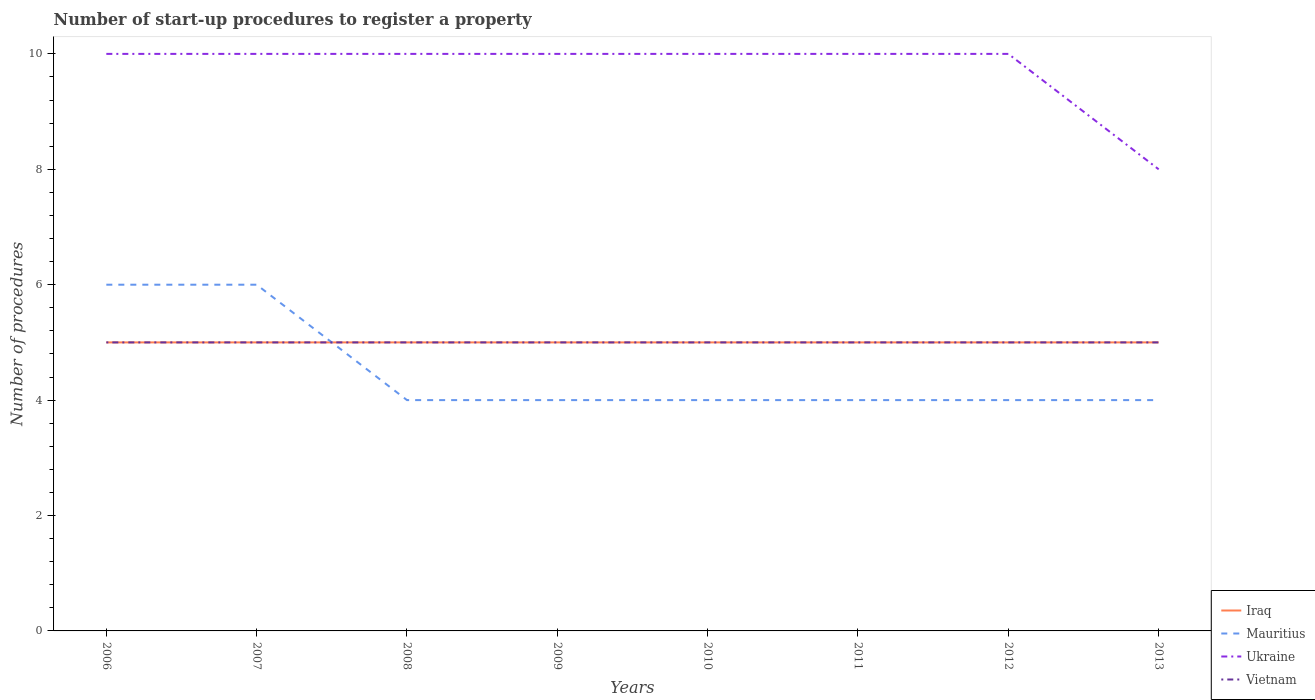Does the line corresponding to Mauritius intersect with the line corresponding to Iraq?
Your response must be concise. Yes. Is the number of lines equal to the number of legend labels?
Your answer should be compact. Yes. Across all years, what is the maximum number of procedures required to register a property in Mauritius?
Offer a terse response. 4. What is the difference between the highest and the second highest number of procedures required to register a property in Ukraine?
Ensure brevity in your answer.  2. How many years are there in the graph?
Offer a very short reply. 8. What is the difference between two consecutive major ticks on the Y-axis?
Keep it short and to the point. 2. Where does the legend appear in the graph?
Provide a short and direct response. Bottom right. How many legend labels are there?
Your answer should be very brief. 4. How are the legend labels stacked?
Provide a short and direct response. Vertical. What is the title of the graph?
Make the answer very short. Number of start-up procedures to register a property. What is the label or title of the X-axis?
Your answer should be very brief. Years. What is the label or title of the Y-axis?
Provide a succinct answer. Number of procedures. What is the Number of procedures of Iraq in 2006?
Your answer should be very brief. 5. What is the Number of procedures of Mauritius in 2006?
Make the answer very short. 6. What is the Number of procedures of Vietnam in 2006?
Your answer should be very brief. 5. What is the Number of procedures in Mauritius in 2007?
Offer a terse response. 6. What is the Number of procedures in Ukraine in 2007?
Keep it short and to the point. 10. What is the Number of procedures in Ukraine in 2008?
Offer a very short reply. 10. What is the Number of procedures of Mauritius in 2009?
Offer a terse response. 4. What is the Number of procedures of Ukraine in 2009?
Offer a terse response. 10. What is the Number of procedures of Vietnam in 2009?
Provide a succinct answer. 5. What is the Number of procedures in Iraq in 2010?
Your response must be concise. 5. What is the Number of procedures of Mauritius in 2010?
Give a very brief answer. 4. What is the Number of procedures of Mauritius in 2011?
Provide a short and direct response. 4. What is the Number of procedures of Ukraine in 2011?
Offer a very short reply. 10. What is the Number of procedures in Vietnam in 2012?
Your response must be concise. 5. What is the Number of procedures of Mauritius in 2013?
Keep it short and to the point. 4. What is the Number of procedures in Ukraine in 2013?
Ensure brevity in your answer.  8. What is the Number of procedures of Vietnam in 2013?
Make the answer very short. 5. Across all years, what is the maximum Number of procedures in Ukraine?
Make the answer very short. 10. Across all years, what is the minimum Number of procedures in Mauritius?
Your answer should be compact. 4. Across all years, what is the minimum Number of procedures in Ukraine?
Provide a short and direct response. 8. What is the total Number of procedures in Mauritius in the graph?
Provide a succinct answer. 36. What is the total Number of procedures in Ukraine in the graph?
Provide a short and direct response. 78. What is the total Number of procedures of Vietnam in the graph?
Make the answer very short. 40. What is the difference between the Number of procedures in Iraq in 2006 and that in 2007?
Give a very brief answer. 0. What is the difference between the Number of procedures in Vietnam in 2006 and that in 2007?
Keep it short and to the point. 0. What is the difference between the Number of procedures of Iraq in 2006 and that in 2008?
Your answer should be compact. 0. What is the difference between the Number of procedures of Vietnam in 2006 and that in 2008?
Ensure brevity in your answer.  0. What is the difference between the Number of procedures of Iraq in 2006 and that in 2009?
Give a very brief answer. 0. What is the difference between the Number of procedures of Ukraine in 2006 and that in 2009?
Your answer should be very brief. 0. What is the difference between the Number of procedures in Vietnam in 2006 and that in 2009?
Your answer should be very brief. 0. What is the difference between the Number of procedures of Mauritius in 2006 and that in 2010?
Offer a very short reply. 2. What is the difference between the Number of procedures of Ukraine in 2006 and that in 2010?
Provide a succinct answer. 0. What is the difference between the Number of procedures of Vietnam in 2006 and that in 2010?
Keep it short and to the point. 0. What is the difference between the Number of procedures in Ukraine in 2006 and that in 2011?
Provide a succinct answer. 0. What is the difference between the Number of procedures of Vietnam in 2006 and that in 2011?
Your answer should be compact. 0. What is the difference between the Number of procedures of Ukraine in 2006 and that in 2012?
Your answer should be compact. 0. What is the difference between the Number of procedures in Vietnam in 2006 and that in 2012?
Provide a succinct answer. 0. What is the difference between the Number of procedures of Iraq in 2006 and that in 2013?
Keep it short and to the point. 0. What is the difference between the Number of procedures of Mauritius in 2006 and that in 2013?
Keep it short and to the point. 2. What is the difference between the Number of procedures in Vietnam in 2006 and that in 2013?
Give a very brief answer. 0. What is the difference between the Number of procedures of Iraq in 2007 and that in 2008?
Your response must be concise. 0. What is the difference between the Number of procedures of Vietnam in 2007 and that in 2008?
Ensure brevity in your answer.  0. What is the difference between the Number of procedures in Ukraine in 2007 and that in 2009?
Provide a short and direct response. 0. What is the difference between the Number of procedures in Iraq in 2007 and that in 2011?
Ensure brevity in your answer.  0. What is the difference between the Number of procedures of Ukraine in 2007 and that in 2011?
Make the answer very short. 0. What is the difference between the Number of procedures in Vietnam in 2007 and that in 2011?
Your response must be concise. 0. What is the difference between the Number of procedures of Mauritius in 2007 and that in 2012?
Offer a terse response. 2. What is the difference between the Number of procedures in Mauritius in 2008 and that in 2009?
Your answer should be compact. 0. What is the difference between the Number of procedures of Ukraine in 2008 and that in 2009?
Offer a terse response. 0. What is the difference between the Number of procedures of Vietnam in 2008 and that in 2009?
Offer a very short reply. 0. What is the difference between the Number of procedures in Iraq in 2008 and that in 2010?
Provide a short and direct response. 0. What is the difference between the Number of procedures of Ukraine in 2008 and that in 2010?
Offer a very short reply. 0. What is the difference between the Number of procedures of Vietnam in 2008 and that in 2010?
Ensure brevity in your answer.  0. What is the difference between the Number of procedures in Mauritius in 2008 and that in 2012?
Your response must be concise. 0. What is the difference between the Number of procedures of Iraq in 2008 and that in 2013?
Make the answer very short. 0. What is the difference between the Number of procedures in Ukraine in 2008 and that in 2013?
Offer a terse response. 2. What is the difference between the Number of procedures of Mauritius in 2009 and that in 2010?
Offer a very short reply. 0. What is the difference between the Number of procedures in Vietnam in 2009 and that in 2010?
Provide a succinct answer. 0. What is the difference between the Number of procedures in Mauritius in 2009 and that in 2011?
Ensure brevity in your answer.  0. What is the difference between the Number of procedures of Ukraine in 2009 and that in 2011?
Ensure brevity in your answer.  0. What is the difference between the Number of procedures of Vietnam in 2009 and that in 2011?
Keep it short and to the point. 0. What is the difference between the Number of procedures of Iraq in 2009 and that in 2012?
Make the answer very short. 0. What is the difference between the Number of procedures in Vietnam in 2009 and that in 2012?
Your answer should be compact. 0. What is the difference between the Number of procedures of Ukraine in 2009 and that in 2013?
Keep it short and to the point. 2. What is the difference between the Number of procedures of Iraq in 2010 and that in 2011?
Offer a terse response. 0. What is the difference between the Number of procedures of Mauritius in 2010 and that in 2011?
Your answer should be very brief. 0. What is the difference between the Number of procedures in Ukraine in 2010 and that in 2011?
Ensure brevity in your answer.  0. What is the difference between the Number of procedures of Vietnam in 2010 and that in 2011?
Ensure brevity in your answer.  0. What is the difference between the Number of procedures of Iraq in 2010 and that in 2012?
Ensure brevity in your answer.  0. What is the difference between the Number of procedures of Mauritius in 2010 and that in 2012?
Make the answer very short. 0. What is the difference between the Number of procedures of Iraq in 2010 and that in 2013?
Your answer should be very brief. 0. What is the difference between the Number of procedures of Mauritius in 2010 and that in 2013?
Your response must be concise. 0. What is the difference between the Number of procedures in Vietnam in 2010 and that in 2013?
Offer a very short reply. 0. What is the difference between the Number of procedures of Iraq in 2011 and that in 2012?
Offer a terse response. 0. What is the difference between the Number of procedures in Mauritius in 2011 and that in 2012?
Your response must be concise. 0. What is the difference between the Number of procedures in Iraq in 2011 and that in 2013?
Provide a succinct answer. 0. What is the difference between the Number of procedures in Ukraine in 2011 and that in 2013?
Provide a succinct answer. 2. What is the difference between the Number of procedures in Mauritius in 2012 and that in 2013?
Your response must be concise. 0. What is the difference between the Number of procedures of Ukraine in 2012 and that in 2013?
Provide a succinct answer. 2. What is the difference between the Number of procedures of Vietnam in 2012 and that in 2013?
Your answer should be compact. 0. What is the difference between the Number of procedures of Iraq in 2006 and the Number of procedures of Mauritius in 2007?
Provide a succinct answer. -1. What is the difference between the Number of procedures in Iraq in 2006 and the Number of procedures in Ukraine in 2007?
Offer a very short reply. -5. What is the difference between the Number of procedures of Mauritius in 2006 and the Number of procedures of Ukraine in 2007?
Offer a very short reply. -4. What is the difference between the Number of procedures of Iraq in 2006 and the Number of procedures of Mauritius in 2008?
Provide a short and direct response. 1. What is the difference between the Number of procedures in Iraq in 2006 and the Number of procedures in Ukraine in 2008?
Your answer should be compact. -5. What is the difference between the Number of procedures of Iraq in 2006 and the Number of procedures of Vietnam in 2008?
Provide a succinct answer. 0. What is the difference between the Number of procedures in Mauritius in 2006 and the Number of procedures in Ukraine in 2008?
Offer a terse response. -4. What is the difference between the Number of procedures in Mauritius in 2006 and the Number of procedures in Vietnam in 2008?
Ensure brevity in your answer.  1. What is the difference between the Number of procedures of Iraq in 2006 and the Number of procedures of Mauritius in 2009?
Your response must be concise. 1. What is the difference between the Number of procedures of Iraq in 2006 and the Number of procedures of Ukraine in 2009?
Make the answer very short. -5. What is the difference between the Number of procedures of Iraq in 2006 and the Number of procedures of Vietnam in 2009?
Offer a very short reply. 0. What is the difference between the Number of procedures in Iraq in 2006 and the Number of procedures in Ukraine in 2010?
Your answer should be very brief. -5. What is the difference between the Number of procedures in Iraq in 2006 and the Number of procedures in Vietnam in 2010?
Make the answer very short. 0. What is the difference between the Number of procedures of Mauritius in 2006 and the Number of procedures of Vietnam in 2010?
Provide a succinct answer. 1. What is the difference between the Number of procedures of Mauritius in 2006 and the Number of procedures of Ukraine in 2011?
Your answer should be very brief. -4. What is the difference between the Number of procedures of Mauritius in 2006 and the Number of procedures of Vietnam in 2011?
Offer a terse response. 1. What is the difference between the Number of procedures of Iraq in 2006 and the Number of procedures of Ukraine in 2012?
Offer a very short reply. -5. What is the difference between the Number of procedures in Iraq in 2006 and the Number of procedures in Vietnam in 2012?
Offer a terse response. 0. What is the difference between the Number of procedures in Mauritius in 2006 and the Number of procedures in Ukraine in 2012?
Your response must be concise. -4. What is the difference between the Number of procedures of Mauritius in 2006 and the Number of procedures of Vietnam in 2012?
Provide a succinct answer. 1. What is the difference between the Number of procedures in Iraq in 2006 and the Number of procedures in Mauritius in 2013?
Your answer should be very brief. 1. What is the difference between the Number of procedures of Mauritius in 2006 and the Number of procedures of Vietnam in 2013?
Give a very brief answer. 1. What is the difference between the Number of procedures of Iraq in 2007 and the Number of procedures of Mauritius in 2008?
Keep it short and to the point. 1. What is the difference between the Number of procedures in Iraq in 2007 and the Number of procedures in Ukraine in 2008?
Your answer should be compact. -5. What is the difference between the Number of procedures in Iraq in 2007 and the Number of procedures in Vietnam in 2008?
Your response must be concise. 0. What is the difference between the Number of procedures of Mauritius in 2007 and the Number of procedures of Vietnam in 2008?
Offer a very short reply. 1. What is the difference between the Number of procedures of Iraq in 2007 and the Number of procedures of Ukraine in 2009?
Ensure brevity in your answer.  -5. What is the difference between the Number of procedures in Iraq in 2007 and the Number of procedures in Vietnam in 2009?
Your response must be concise. 0. What is the difference between the Number of procedures in Mauritius in 2007 and the Number of procedures in Ukraine in 2009?
Offer a terse response. -4. What is the difference between the Number of procedures of Iraq in 2007 and the Number of procedures of Ukraine in 2010?
Keep it short and to the point. -5. What is the difference between the Number of procedures in Mauritius in 2007 and the Number of procedures in Vietnam in 2010?
Your response must be concise. 1. What is the difference between the Number of procedures in Mauritius in 2007 and the Number of procedures in Ukraine in 2011?
Your answer should be very brief. -4. What is the difference between the Number of procedures of Mauritius in 2007 and the Number of procedures of Vietnam in 2011?
Your answer should be compact. 1. What is the difference between the Number of procedures of Ukraine in 2007 and the Number of procedures of Vietnam in 2011?
Give a very brief answer. 5. What is the difference between the Number of procedures of Iraq in 2007 and the Number of procedures of Ukraine in 2012?
Your response must be concise. -5. What is the difference between the Number of procedures of Mauritius in 2007 and the Number of procedures of Vietnam in 2012?
Provide a succinct answer. 1. What is the difference between the Number of procedures of Ukraine in 2007 and the Number of procedures of Vietnam in 2012?
Keep it short and to the point. 5. What is the difference between the Number of procedures of Iraq in 2007 and the Number of procedures of Mauritius in 2013?
Provide a short and direct response. 1. What is the difference between the Number of procedures in Iraq in 2007 and the Number of procedures in Ukraine in 2013?
Keep it short and to the point. -3. What is the difference between the Number of procedures of Iraq in 2008 and the Number of procedures of Ukraine in 2009?
Ensure brevity in your answer.  -5. What is the difference between the Number of procedures of Iraq in 2008 and the Number of procedures of Vietnam in 2009?
Your answer should be very brief. 0. What is the difference between the Number of procedures in Mauritius in 2008 and the Number of procedures in Ukraine in 2009?
Ensure brevity in your answer.  -6. What is the difference between the Number of procedures in Ukraine in 2008 and the Number of procedures in Vietnam in 2009?
Ensure brevity in your answer.  5. What is the difference between the Number of procedures in Iraq in 2008 and the Number of procedures in Mauritius in 2010?
Offer a very short reply. 1. What is the difference between the Number of procedures in Iraq in 2008 and the Number of procedures in Ukraine in 2010?
Provide a succinct answer. -5. What is the difference between the Number of procedures in Iraq in 2008 and the Number of procedures in Vietnam in 2010?
Provide a short and direct response. 0. What is the difference between the Number of procedures of Mauritius in 2008 and the Number of procedures of Vietnam in 2010?
Keep it short and to the point. -1. What is the difference between the Number of procedures of Iraq in 2008 and the Number of procedures of Mauritius in 2011?
Provide a succinct answer. 1. What is the difference between the Number of procedures of Iraq in 2008 and the Number of procedures of Ukraine in 2011?
Make the answer very short. -5. What is the difference between the Number of procedures in Iraq in 2008 and the Number of procedures in Vietnam in 2011?
Give a very brief answer. 0. What is the difference between the Number of procedures of Ukraine in 2008 and the Number of procedures of Vietnam in 2011?
Your response must be concise. 5. What is the difference between the Number of procedures of Iraq in 2008 and the Number of procedures of Mauritius in 2012?
Make the answer very short. 1. What is the difference between the Number of procedures of Iraq in 2008 and the Number of procedures of Ukraine in 2012?
Provide a succinct answer. -5. What is the difference between the Number of procedures in Mauritius in 2008 and the Number of procedures in Ukraine in 2012?
Provide a succinct answer. -6. What is the difference between the Number of procedures in Mauritius in 2008 and the Number of procedures in Vietnam in 2012?
Your answer should be very brief. -1. What is the difference between the Number of procedures of Ukraine in 2008 and the Number of procedures of Vietnam in 2012?
Your response must be concise. 5. What is the difference between the Number of procedures of Iraq in 2008 and the Number of procedures of Ukraine in 2013?
Provide a succinct answer. -3. What is the difference between the Number of procedures of Iraq in 2008 and the Number of procedures of Vietnam in 2013?
Your answer should be very brief. 0. What is the difference between the Number of procedures of Mauritius in 2008 and the Number of procedures of Ukraine in 2013?
Ensure brevity in your answer.  -4. What is the difference between the Number of procedures in Mauritius in 2008 and the Number of procedures in Vietnam in 2013?
Offer a very short reply. -1. What is the difference between the Number of procedures in Iraq in 2009 and the Number of procedures in Ukraine in 2011?
Make the answer very short. -5. What is the difference between the Number of procedures of Iraq in 2009 and the Number of procedures of Vietnam in 2011?
Give a very brief answer. 0. What is the difference between the Number of procedures of Mauritius in 2009 and the Number of procedures of Ukraine in 2011?
Provide a short and direct response. -6. What is the difference between the Number of procedures of Ukraine in 2009 and the Number of procedures of Vietnam in 2011?
Offer a very short reply. 5. What is the difference between the Number of procedures in Iraq in 2009 and the Number of procedures in Mauritius in 2013?
Provide a short and direct response. 1. What is the difference between the Number of procedures in Iraq in 2009 and the Number of procedures in Vietnam in 2013?
Your response must be concise. 0. What is the difference between the Number of procedures of Mauritius in 2009 and the Number of procedures of Ukraine in 2013?
Your answer should be very brief. -4. What is the difference between the Number of procedures in Iraq in 2010 and the Number of procedures in Mauritius in 2011?
Keep it short and to the point. 1. What is the difference between the Number of procedures in Iraq in 2010 and the Number of procedures in Ukraine in 2011?
Make the answer very short. -5. What is the difference between the Number of procedures in Ukraine in 2010 and the Number of procedures in Vietnam in 2011?
Keep it short and to the point. 5. What is the difference between the Number of procedures of Iraq in 2010 and the Number of procedures of Vietnam in 2012?
Keep it short and to the point. 0. What is the difference between the Number of procedures of Mauritius in 2010 and the Number of procedures of Ukraine in 2012?
Give a very brief answer. -6. What is the difference between the Number of procedures in Iraq in 2010 and the Number of procedures in Mauritius in 2013?
Provide a succinct answer. 1. What is the difference between the Number of procedures of Ukraine in 2010 and the Number of procedures of Vietnam in 2013?
Offer a very short reply. 5. What is the difference between the Number of procedures of Iraq in 2011 and the Number of procedures of Mauritius in 2012?
Provide a short and direct response. 1. What is the difference between the Number of procedures of Mauritius in 2011 and the Number of procedures of Vietnam in 2012?
Your answer should be compact. -1. What is the difference between the Number of procedures of Ukraine in 2011 and the Number of procedures of Vietnam in 2012?
Ensure brevity in your answer.  5. What is the difference between the Number of procedures of Iraq in 2011 and the Number of procedures of Ukraine in 2013?
Offer a very short reply. -3. What is the difference between the Number of procedures of Iraq in 2011 and the Number of procedures of Vietnam in 2013?
Your answer should be compact. 0. What is the difference between the Number of procedures in Mauritius in 2011 and the Number of procedures in Vietnam in 2013?
Give a very brief answer. -1. What is the difference between the Number of procedures of Ukraine in 2011 and the Number of procedures of Vietnam in 2013?
Ensure brevity in your answer.  5. What is the difference between the Number of procedures of Iraq in 2012 and the Number of procedures of Mauritius in 2013?
Provide a succinct answer. 1. What is the difference between the Number of procedures in Iraq in 2012 and the Number of procedures in Ukraine in 2013?
Your answer should be compact. -3. What is the difference between the Number of procedures in Iraq in 2012 and the Number of procedures in Vietnam in 2013?
Your answer should be compact. 0. What is the difference between the Number of procedures of Mauritius in 2012 and the Number of procedures of Ukraine in 2013?
Your answer should be very brief. -4. What is the average Number of procedures in Mauritius per year?
Your response must be concise. 4.5. What is the average Number of procedures in Ukraine per year?
Ensure brevity in your answer.  9.75. What is the average Number of procedures of Vietnam per year?
Ensure brevity in your answer.  5. In the year 2006, what is the difference between the Number of procedures in Iraq and Number of procedures in Mauritius?
Offer a very short reply. -1. In the year 2006, what is the difference between the Number of procedures in Iraq and Number of procedures in Vietnam?
Keep it short and to the point. 0. In the year 2006, what is the difference between the Number of procedures in Mauritius and Number of procedures in Vietnam?
Provide a succinct answer. 1. In the year 2006, what is the difference between the Number of procedures of Ukraine and Number of procedures of Vietnam?
Make the answer very short. 5. In the year 2007, what is the difference between the Number of procedures in Mauritius and Number of procedures in Ukraine?
Provide a succinct answer. -4. In the year 2007, what is the difference between the Number of procedures in Ukraine and Number of procedures in Vietnam?
Keep it short and to the point. 5. In the year 2008, what is the difference between the Number of procedures in Iraq and Number of procedures in Mauritius?
Make the answer very short. 1. In the year 2008, what is the difference between the Number of procedures in Iraq and Number of procedures in Vietnam?
Provide a succinct answer. 0. In the year 2009, what is the difference between the Number of procedures of Iraq and Number of procedures of Ukraine?
Make the answer very short. -5. In the year 2009, what is the difference between the Number of procedures in Iraq and Number of procedures in Vietnam?
Your response must be concise. 0. In the year 2009, what is the difference between the Number of procedures of Mauritius and Number of procedures of Ukraine?
Give a very brief answer. -6. In the year 2010, what is the difference between the Number of procedures in Iraq and Number of procedures in Mauritius?
Keep it short and to the point. 1. In the year 2010, what is the difference between the Number of procedures in Iraq and Number of procedures in Vietnam?
Make the answer very short. 0. In the year 2010, what is the difference between the Number of procedures in Ukraine and Number of procedures in Vietnam?
Provide a succinct answer. 5. In the year 2011, what is the difference between the Number of procedures of Iraq and Number of procedures of Mauritius?
Provide a succinct answer. 1. In the year 2011, what is the difference between the Number of procedures in Iraq and Number of procedures in Ukraine?
Offer a very short reply. -5. In the year 2011, what is the difference between the Number of procedures in Iraq and Number of procedures in Vietnam?
Keep it short and to the point. 0. In the year 2011, what is the difference between the Number of procedures of Mauritius and Number of procedures of Ukraine?
Offer a terse response. -6. In the year 2011, what is the difference between the Number of procedures of Ukraine and Number of procedures of Vietnam?
Provide a short and direct response. 5. In the year 2012, what is the difference between the Number of procedures in Iraq and Number of procedures in Mauritius?
Your response must be concise. 1. In the year 2012, what is the difference between the Number of procedures of Iraq and Number of procedures of Ukraine?
Ensure brevity in your answer.  -5. In the year 2012, what is the difference between the Number of procedures of Iraq and Number of procedures of Vietnam?
Your response must be concise. 0. In the year 2013, what is the difference between the Number of procedures in Iraq and Number of procedures in Mauritius?
Your answer should be very brief. 1. In the year 2013, what is the difference between the Number of procedures in Iraq and Number of procedures in Ukraine?
Keep it short and to the point. -3. In the year 2013, what is the difference between the Number of procedures of Iraq and Number of procedures of Vietnam?
Your response must be concise. 0. In the year 2013, what is the difference between the Number of procedures of Mauritius and Number of procedures of Ukraine?
Provide a succinct answer. -4. In the year 2013, what is the difference between the Number of procedures of Mauritius and Number of procedures of Vietnam?
Offer a very short reply. -1. What is the ratio of the Number of procedures in Iraq in 2006 to that in 2007?
Make the answer very short. 1. What is the ratio of the Number of procedures of Vietnam in 2006 to that in 2007?
Provide a short and direct response. 1. What is the ratio of the Number of procedures of Iraq in 2006 to that in 2008?
Offer a very short reply. 1. What is the ratio of the Number of procedures of Mauritius in 2006 to that in 2008?
Provide a short and direct response. 1.5. What is the ratio of the Number of procedures in Ukraine in 2006 to that in 2008?
Offer a very short reply. 1. What is the ratio of the Number of procedures in Iraq in 2006 to that in 2009?
Your response must be concise. 1. What is the ratio of the Number of procedures of Ukraine in 2006 to that in 2009?
Offer a terse response. 1. What is the ratio of the Number of procedures of Vietnam in 2006 to that in 2009?
Provide a succinct answer. 1. What is the ratio of the Number of procedures of Iraq in 2006 to that in 2010?
Your answer should be compact. 1. What is the ratio of the Number of procedures of Mauritius in 2006 to that in 2010?
Make the answer very short. 1.5. What is the ratio of the Number of procedures of Ukraine in 2006 to that in 2010?
Offer a very short reply. 1. What is the ratio of the Number of procedures in Vietnam in 2006 to that in 2010?
Make the answer very short. 1. What is the ratio of the Number of procedures in Iraq in 2006 to that in 2011?
Ensure brevity in your answer.  1. What is the ratio of the Number of procedures in Mauritius in 2006 to that in 2011?
Your response must be concise. 1.5. What is the ratio of the Number of procedures of Ukraine in 2006 to that in 2011?
Your answer should be very brief. 1. What is the ratio of the Number of procedures of Vietnam in 2006 to that in 2011?
Provide a short and direct response. 1. What is the ratio of the Number of procedures in Iraq in 2006 to that in 2012?
Your answer should be compact. 1. What is the ratio of the Number of procedures of Vietnam in 2006 to that in 2012?
Keep it short and to the point. 1. What is the ratio of the Number of procedures in Iraq in 2006 to that in 2013?
Ensure brevity in your answer.  1. What is the ratio of the Number of procedures of Mauritius in 2006 to that in 2013?
Your response must be concise. 1.5. What is the ratio of the Number of procedures of Ukraine in 2006 to that in 2013?
Give a very brief answer. 1.25. What is the ratio of the Number of procedures in Vietnam in 2006 to that in 2013?
Offer a terse response. 1. What is the ratio of the Number of procedures of Mauritius in 2007 to that in 2008?
Offer a very short reply. 1.5. What is the ratio of the Number of procedures in Iraq in 2007 to that in 2009?
Your answer should be very brief. 1. What is the ratio of the Number of procedures in Vietnam in 2007 to that in 2009?
Give a very brief answer. 1. What is the ratio of the Number of procedures of Mauritius in 2007 to that in 2011?
Your answer should be very brief. 1.5. What is the ratio of the Number of procedures of Ukraine in 2007 to that in 2011?
Give a very brief answer. 1. What is the ratio of the Number of procedures of Vietnam in 2007 to that in 2011?
Ensure brevity in your answer.  1. What is the ratio of the Number of procedures in Mauritius in 2007 to that in 2012?
Provide a succinct answer. 1.5. What is the ratio of the Number of procedures of Ukraine in 2007 to that in 2012?
Offer a very short reply. 1. What is the ratio of the Number of procedures in Vietnam in 2007 to that in 2012?
Provide a short and direct response. 1. What is the ratio of the Number of procedures of Iraq in 2007 to that in 2013?
Offer a very short reply. 1. What is the ratio of the Number of procedures of Ukraine in 2007 to that in 2013?
Give a very brief answer. 1.25. What is the ratio of the Number of procedures of Mauritius in 2008 to that in 2009?
Your response must be concise. 1. What is the ratio of the Number of procedures of Ukraine in 2008 to that in 2009?
Make the answer very short. 1. What is the ratio of the Number of procedures in Vietnam in 2008 to that in 2009?
Your answer should be compact. 1. What is the ratio of the Number of procedures in Mauritius in 2008 to that in 2010?
Provide a short and direct response. 1. What is the ratio of the Number of procedures in Ukraine in 2008 to that in 2010?
Provide a succinct answer. 1. What is the ratio of the Number of procedures in Iraq in 2008 to that in 2012?
Your answer should be very brief. 1. What is the ratio of the Number of procedures of Mauritius in 2008 to that in 2012?
Offer a very short reply. 1. What is the ratio of the Number of procedures in Ukraine in 2008 to that in 2012?
Offer a very short reply. 1. What is the ratio of the Number of procedures of Vietnam in 2008 to that in 2012?
Your answer should be compact. 1. What is the ratio of the Number of procedures in Iraq in 2008 to that in 2013?
Make the answer very short. 1. What is the ratio of the Number of procedures in Mauritius in 2009 to that in 2010?
Make the answer very short. 1. What is the ratio of the Number of procedures of Ukraine in 2009 to that in 2010?
Your answer should be very brief. 1. What is the ratio of the Number of procedures in Iraq in 2009 to that in 2011?
Your answer should be compact. 1. What is the ratio of the Number of procedures in Mauritius in 2009 to that in 2011?
Keep it short and to the point. 1. What is the ratio of the Number of procedures in Ukraine in 2009 to that in 2011?
Your answer should be very brief. 1. What is the ratio of the Number of procedures in Vietnam in 2009 to that in 2011?
Provide a short and direct response. 1. What is the ratio of the Number of procedures in Mauritius in 2009 to that in 2013?
Offer a very short reply. 1. What is the ratio of the Number of procedures of Vietnam in 2009 to that in 2013?
Keep it short and to the point. 1. What is the ratio of the Number of procedures in Iraq in 2010 to that in 2011?
Give a very brief answer. 1. What is the ratio of the Number of procedures of Mauritius in 2010 to that in 2012?
Offer a very short reply. 1. What is the ratio of the Number of procedures of Ukraine in 2010 to that in 2012?
Provide a short and direct response. 1. What is the ratio of the Number of procedures of Vietnam in 2010 to that in 2012?
Give a very brief answer. 1. What is the ratio of the Number of procedures in Iraq in 2010 to that in 2013?
Ensure brevity in your answer.  1. What is the ratio of the Number of procedures in Ukraine in 2011 to that in 2012?
Keep it short and to the point. 1. What is the ratio of the Number of procedures of Vietnam in 2011 to that in 2012?
Your answer should be very brief. 1. What is the ratio of the Number of procedures in Mauritius in 2011 to that in 2013?
Keep it short and to the point. 1. What is the ratio of the Number of procedures of Vietnam in 2011 to that in 2013?
Offer a very short reply. 1. What is the ratio of the Number of procedures in Iraq in 2012 to that in 2013?
Offer a terse response. 1. What is the ratio of the Number of procedures of Ukraine in 2012 to that in 2013?
Provide a succinct answer. 1.25. What is the ratio of the Number of procedures of Vietnam in 2012 to that in 2013?
Ensure brevity in your answer.  1. What is the difference between the highest and the second highest Number of procedures in Mauritius?
Ensure brevity in your answer.  0. What is the difference between the highest and the lowest Number of procedures of Ukraine?
Provide a short and direct response. 2. 